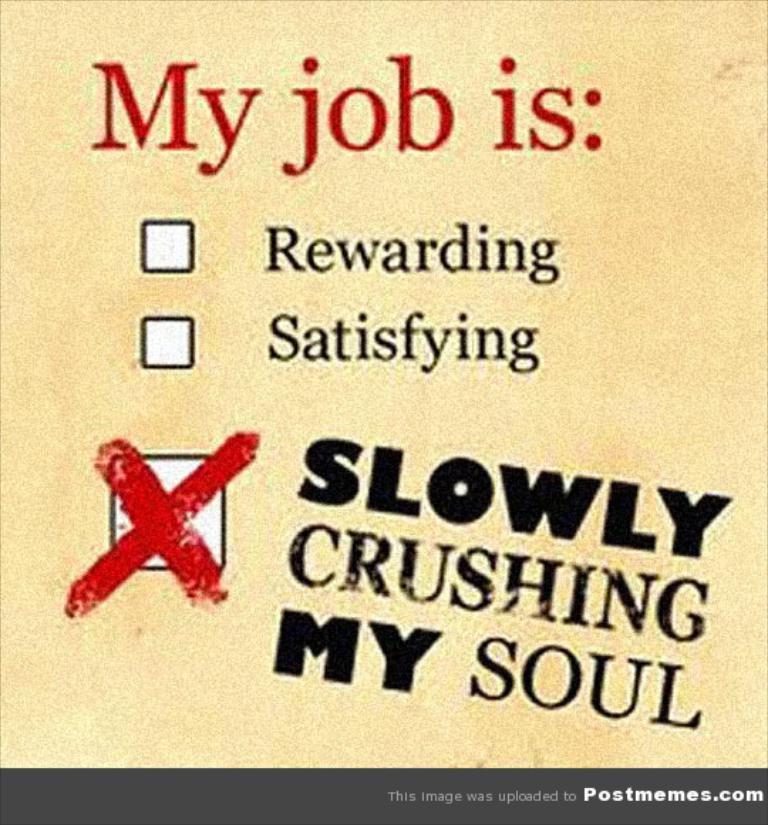What is the ad promoting?
Keep it short and to the point. Unanswerable. What is slowly crushing my soul?
Make the answer very short. My job. 